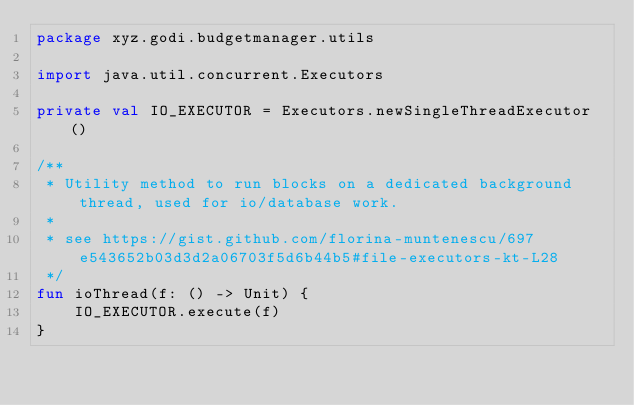Convert code to text. <code><loc_0><loc_0><loc_500><loc_500><_Kotlin_>package xyz.godi.budgetmanager.utils

import java.util.concurrent.Executors

private val IO_EXECUTOR = Executors.newSingleThreadExecutor()

/**
 * Utility method to run blocks on a dedicated background thread, used for io/database work.
 *
 * see https://gist.github.com/florina-muntenescu/697e543652b03d3d2a06703f5d6b44b5#file-executors-kt-L28
 */
fun ioThread(f: () -> Unit) {
    IO_EXECUTOR.execute(f)
}</code> 